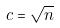<formula> <loc_0><loc_0><loc_500><loc_500>c = \sqrt { n }</formula> 